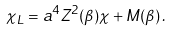Convert formula to latex. <formula><loc_0><loc_0><loc_500><loc_500>\chi _ { L } = a ^ { 4 } Z ^ { 2 } ( \beta ) \chi + M ( \beta ) \, .</formula> 